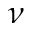<formula> <loc_0><loc_0><loc_500><loc_500>\nu</formula> 